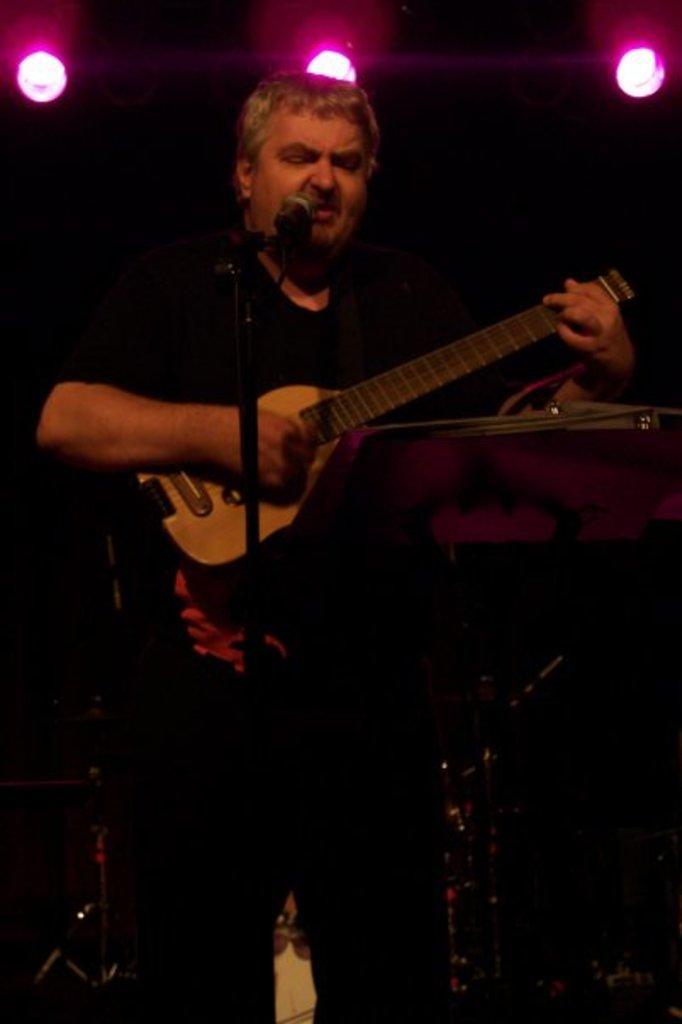Could you give a brief overview of what you see in this image? There is a man singing in microphone and playing guitar and wearing black costume. 